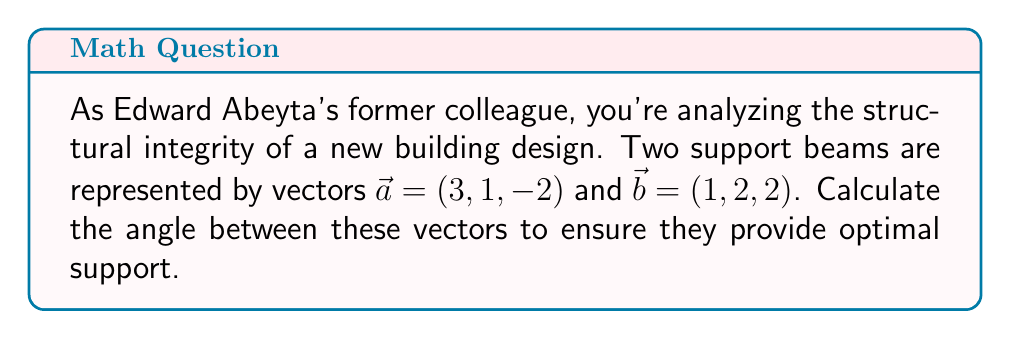Show me your answer to this math problem. To find the angle between two vectors in three-dimensional space, we use the dot product formula:

$$\cos \theta = \frac{\vec{a} \cdot \vec{b}}{|\vec{a}| |\vec{b}|}$$

Step 1: Calculate the dot product $\vec{a} \cdot \vec{b}$
$$\vec{a} \cdot \vec{b} = (3)(1) + (1)(2) + (-2)(2) = 3 + 2 - 4 = 1$$

Step 2: Calculate the magnitudes of $\vec{a}$ and $\vec{b}$
$$|\vec{a}| = \sqrt{3^2 + 1^2 + (-2)^2} = \sqrt{9 + 1 + 4} = \sqrt{14}$$
$$|\vec{b}| = \sqrt{1^2 + 2^2 + 2^2} = \sqrt{1 + 4 + 4} = 3$$

Step 3: Substitute into the formula
$$\cos \theta = \frac{1}{\sqrt{14} \cdot 3} = \frac{1}{3\sqrt{14}}$$

Step 4: Take the inverse cosine (arccos) of both sides
$$\theta = \arccos\left(\frac{1}{3\sqrt{14}}\right)$$

Step 5: Calculate the result (rounded to two decimal places)
$$\theta \approx 1.39 \text{ radians} \approx 79.61°$$
Answer: $79.61°$ 